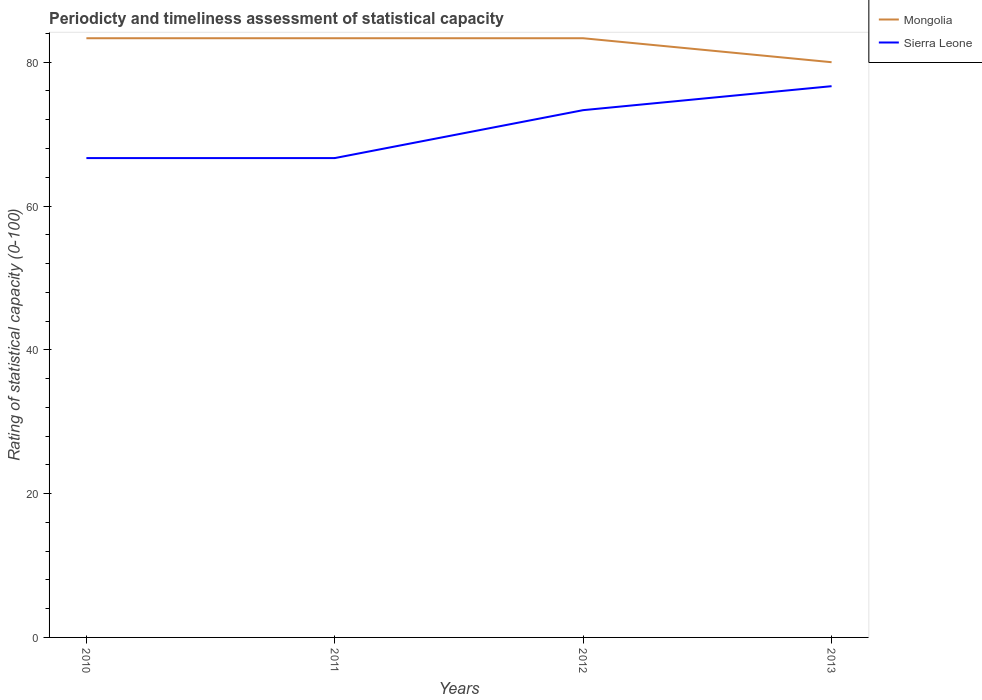How many different coloured lines are there?
Provide a short and direct response. 2. Across all years, what is the maximum rating of statistical capacity in Sierra Leone?
Give a very brief answer. 66.67. What is the total rating of statistical capacity in Mongolia in the graph?
Offer a very short reply. 3.33. What is the difference between the highest and the second highest rating of statistical capacity in Sierra Leone?
Provide a short and direct response. 10. What is the difference between the highest and the lowest rating of statistical capacity in Sierra Leone?
Give a very brief answer. 2. Is the rating of statistical capacity in Mongolia strictly greater than the rating of statistical capacity in Sierra Leone over the years?
Provide a succinct answer. No. How many lines are there?
Offer a terse response. 2. What is the difference between two consecutive major ticks on the Y-axis?
Offer a terse response. 20. Where does the legend appear in the graph?
Keep it short and to the point. Top right. What is the title of the graph?
Keep it short and to the point. Periodicty and timeliness assessment of statistical capacity. Does "Iran" appear as one of the legend labels in the graph?
Your answer should be compact. No. What is the label or title of the X-axis?
Make the answer very short. Years. What is the label or title of the Y-axis?
Provide a succinct answer. Rating of statistical capacity (0-100). What is the Rating of statistical capacity (0-100) of Mongolia in 2010?
Ensure brevity in your answer.  83.33. What is the Rating of statistical capacity (0-100) in Sierra Leone in 2010?
Your answer should be compact. 66.67. What is the Rating of statistical capacity (0-100) of Mongolia in 2011?
Provide a succinct answer. 83.33. What is the Rating of statistical capacity (0-100) of Sierra Leone in 2011?
Ensure brevity in your answer.  66.67. What is the Rating of statistical capacity (0-100) of Mongolia in 2012?
Give a very brief answer. 83.33. What is the Rating of statistical capacity (0-100) of Sierra Leone in 2012?
Provide a succinct answer. 73.33. What is the Rating of statistical capacity (0-100) in Mongolia in 2013?
Keep it short and to the point. 80. What is the Rating of statistical capacity (0-100) in Sierra Leone in 2013?
Offer a terse response. 76.67. Across all years, what is the maximum Rating of statistical capacity (0-100) in Mongolia?
Give a very brief answer. 83.33. Across all years, what is the maximum Rating of statistical capacity (0-100) of Sierra Leone?
Provide a short and direct response. 76.67. Across all years, what is the minimum Rating of statistical capacity (0-100) of Mongolia?
Offer a terse response. 80. Across all years, what is the minimum Rating of statistical capacity (0-100) of Sierra Leone?
Give a very brief answer. 66.67. What is the total Rating of statistical capacity (0-100) in Mongolia in the graph?
Provide a succinct answer. 330. What is the total Rating of statistical capacity (0-100) of Sierra Leone in the graph?
Provide a short and direct response. 283.33. What is the difference between the Rating of statistical capacity (0-100) of Sierra Leone in 2010 and that in 2012?
Provide a short and direct response. -6.67. What is the difference between the Rating of statistical capacity (0-100) of Sierra Leone in 2010 and that in 2013?
Provide a succinct answer. -10. What is the difference between the Rating of statistical capacity (0-100) in Sierra Leone in 2011 and that in 2012?
Your answer should be compact. -6.67. What is the difference between the Rating of statistical capacity (0-100) of Mongolia in 2011 and that in 2013?
Offer a very short reply. 3.33. What is the difference between the Rating of statistical capacity (0-100) of Sierra Leone in 2011 and that in 2013?
Your answer should be compact. -10. What is the difference between the Rating of statistical capacity (0-100) in Mongolia in 2012 and that in 2013?
Provide a succinct answer. 3.33. What is the difference between the Rating of statistical capacity (0-100) in Mongolia in 2010 and the Rating of statistical capacity (0-100) in Sierra Leone in 2011?
Give a very brief answer. 16.67. What is the difference between the Rating of statistical capacity (0-100) in Mongolia in 2010 and the Rating of statistical capacity (0-100) in Sierra Leone in 2013?
Offer a terse response. 6.67. What is the difference between the Rating of statistical capacity (0-100) of Mongolia in 2012 and the Rating of statistical capacity (0-100) of Sierra Leone in 2013?
Your response must be concise. 6.67. What is the average Rating of statistical capacity (0-100) of Mongolia per year?
Make the answer very short. 82.5. What is the average Rating of statistical capacity (0-100) of Sierra Leone per year?
Offer a very short reply. 70.83. In the year 2010, what is the difference between the Rating of statistical capacity (0-100) in Mongolia and Rating of statistical capacity (0-100) in Sierra Leone?
Ensure brevity in your answer.  16.67. In the year 2011, what is the difference between the Rating of statistical capacity (0-100) of Mongolia and Rating of statistical capacity (0-100) of Sierra Leone?
Your answer should be very brief. 16.67. In the year 2012, what is the difference between the Rating of statistical capacity (0-100) of Mongolia and Rating of statistical capacity (0-100) of Sierra Leone?
Make the answer very short. 10. In the year 2013, what is the difference between the Rating of statistical capacity (0-100) in Mongolia and Rating of statistical capacity (0-100) in Sierra Leone?
Make the answer very short. 3.33. What is the ratio of the Rating of statistical capacity (0-100) of Mongolia in 2010 to that in 2011?
Give a very brief answer. 1. What is the ratio of the Rating of statistical capacity (0-100) of Sierra Leone in 2010 to that in 2011?
Offer a terse response. 1. What is the ratio of the Rating of statistical capacity (0-100) in Mongolia in 2010 to that in 2012?
Give a very brief answer. 1. What is the ratio of the Rating of statistical capacity (0-100) of Mongolia in 2010 to that in 2013?
Your response must be concise. 1.04. What is the ratio of the Rating of statistical capacity (0-100) in Sierra Leone in 2010 to that in 2013?
Offer a very short reply. 0.87. What is the ratio of the Rating of statistical capacity (0-100) in Mongolia in 2011 to that in 2012?
Keep it short and to the point. 1. What is the ratio of the Rating of statistical capacity (0-100) in Sierra Leone in 2011 to that in 2012?
Your answer should be very brief. 0.91. What is the ratio of the Rating of statistical capacity (0-100) in Mongolia in 2011 to that in 2013?
Make the answer very short. 1.04. What is the ratio of the Rating of statistical capacity (0-100) of Sierra Leone in 2011 to that in 2013?
Your answer should be compact. 0.87. What is the ratio of the Rating of statistical capacity (0-100) of Mongolia in 2012 to that in 2013?
Provide a succinct answer. 1.04. What is the ratio of the Rating of statistical capacity (0-100) in Sierra Leone in 2012 to that in 2013?
Provide a succinct answer. 0.96. What is the difference between the highest and the lowest Rating of statistical capacity (0-100) of Mongolia?
Give a very brief answer. 3.33. What is the difference between the highest and the lowest Rating of statistical capacity (0-100) of Sierra Leone?
Offer a terse response. 10. 